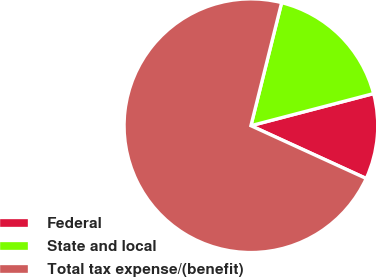Convert chart to OTSL. <chart><loc_0><loc_0><loc_500><loc_500><pie_chart><fcel>Federal<fcel>State and local<fcel>Total tax expense/(benefit)<nl><fcel>10.91%<fcel>17.03%<fcel>72.06%<nl></chart> 